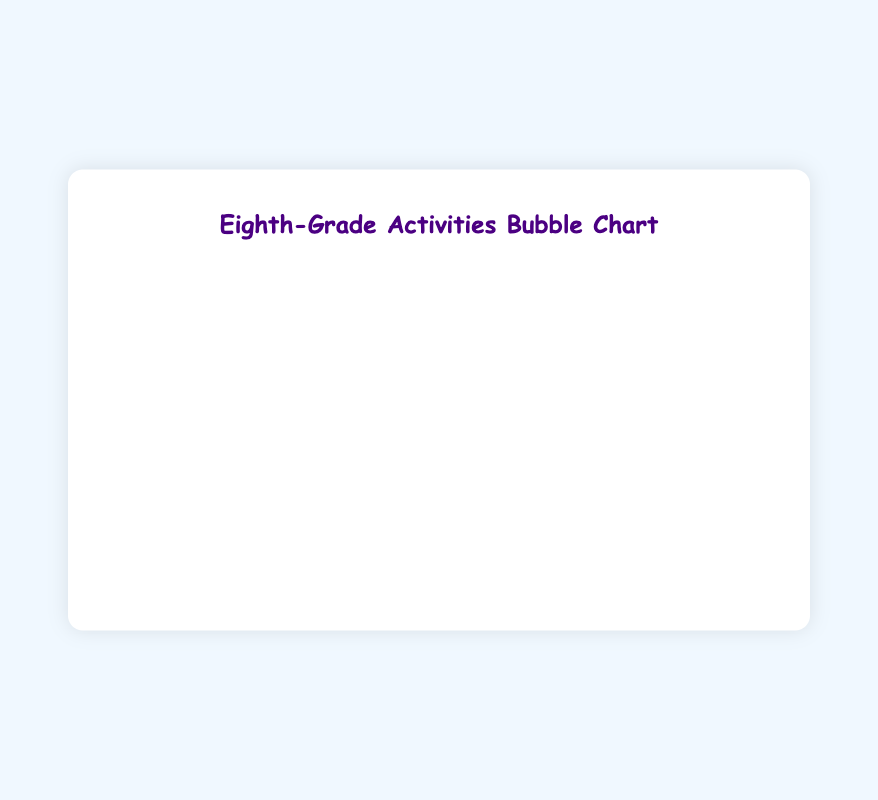What's the most time-consuming activity among eighth-grade students? By looking at the x-axis which represents time spent per week, the bubble furthest to the right corresponds to Video Games at 10 hours per week.
Answer: Video Games Which activity has the highest number of participants? By looking at the y-axis which represents the number of participants, the bubble at the highest point corresponds to Football with 50 participants.
Answer: Football How many activities fall under the 'Medium' intensity category? By checking the tooltip or datalabels, activities with 'Medium' intensity are Basketball, Baseball, and Swimming.
Answer: 3 Which activity involves the lowest number of participants and how many are there? By examining the lowest bubble on the y-axis, 'Other' activity involves the least participants with only 10.
Answer: Other with 10 participants What is the combined number of participants in Football and Soccer? Football has 50 participants and Soccer has 35 participants, summed together (50 + 35) there are 85 participants.
Answer: 85 Compare the time spent per week between Basketball and Baseball. Which one is greater and by how much? Basketball is 6 hours/week and Baseball is 5 hours/week. The difference is (6 - 5) = 1 hour.
Answer: Basketball by 1 hour Between Football and Video Games, which activity has more participants and how many more? Football has 50 participants, Video Games has 45. The difference is (50 - 45) = 5 participants.
Answer: Football by 5 participants What is the average time spent per week across all activities? Sum all the time spent values (8 + 6 + 7 + 5 + 4 + 3 + 10 + 2) = 45. Divide by the number of activities (8). So, 45 / 8 = 5.625 hours/week.
Answer: 5.625 hours/week Which activity listed under 'High' intensity has more participants, Football or Soccer? Checking the 'High' intensity activities, Football has 50 participants and Soccer has 35 participants.
Answer: Football What is the size of the circle (radius) associated with Running in the bubble chart? By looking closely at the Running bubble, the radius (size of the circle) corresponding to Running is 10.
Answer: 10 